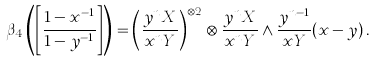<formula> <loc_0><loc_0><loc_500><loc_500>\beta _ { 4 } \left ( \left [ \frac { 1 - x ^ { - 1 } } { 1 - y ^ { - 1 } } \right ] \right ) = \left ( \frac { y ^ { n } X } { x ^ { n } Y } \right ) ^ { \otimes 2 } \otimes \frac { y ^ { n } X } { x ^ { n } Y } \wedge \frac { y ^ { n - 1 } } { x Y } ( x - y ) \, .</formula> 